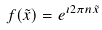<formula> <loc_0><loc_0><loc_500><loc_500>f ( \tilde { x } ) = e ^ { \imath 2 \pi n \tilde { x } }</formula> 